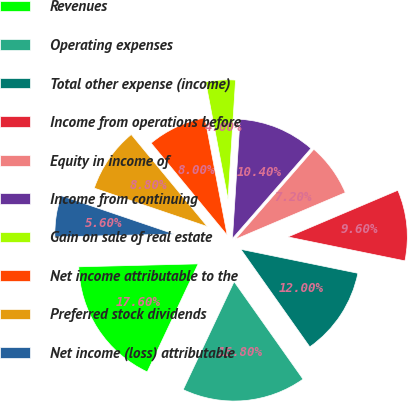Convert chart. <chart><loc_0><loc_0><loc_500><loc_500><pie_chart><fcel>Revenues<fcel>Operating expenses<fcel>Total other expense (income)<fcel>Income from operations before<fcel>Equity in income of<fcel>Income from continuing<fcel>Gain on sale of real estate<fcel>Net income attributable to the<fcel>Preferred stock dividends<fcel>Net income (loss) attributable<nl><fcel>17.6%<fcel>16.8%<fcel>12.0%<fcel>9.6%<fcel>7.2%<fcel>10.4%<fcel>4.0%<fcel>8.0%<fcel>8.8%<fcel>5.6%<nl></chart> 